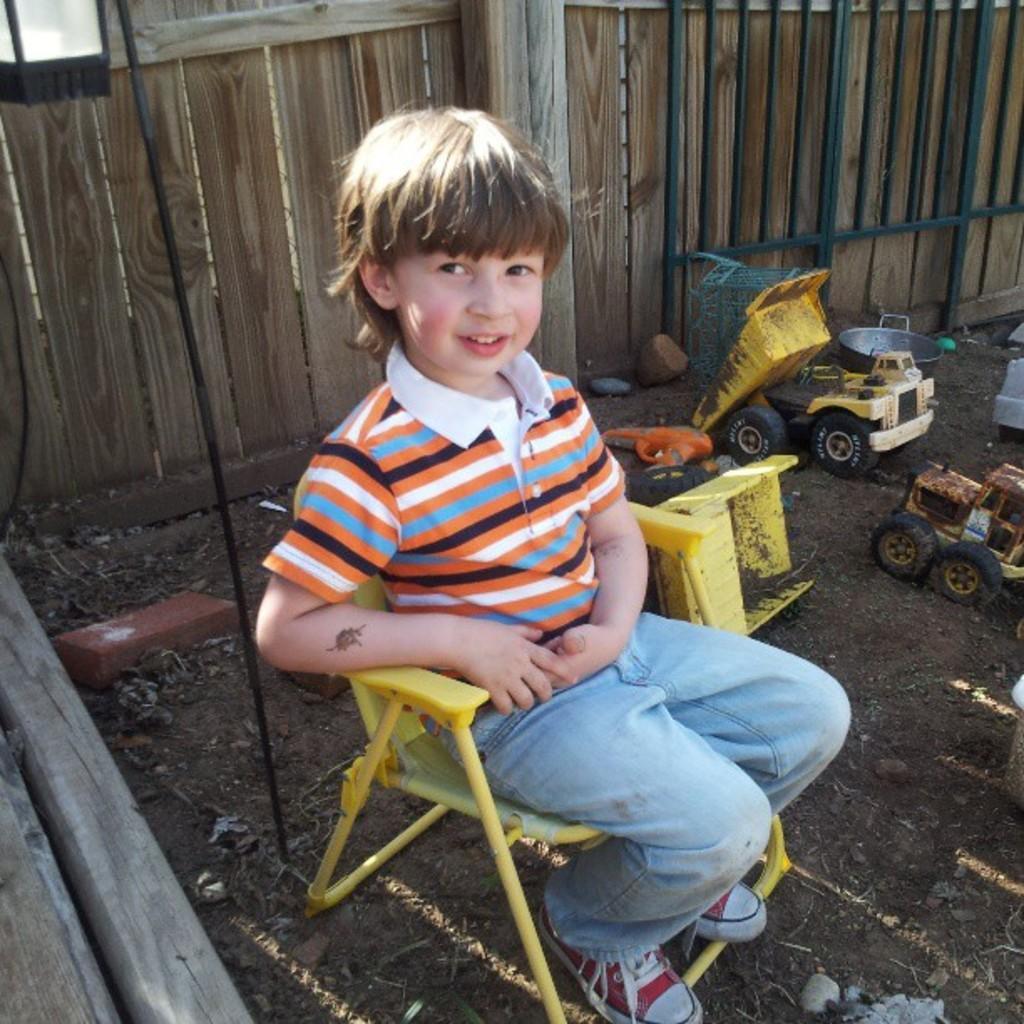Describe this image in one or two sentences. The kid wearing a blue jeans is sitting in a yellow chair and there are toys which are on the ground beside the kid and the background is wooden fence. 